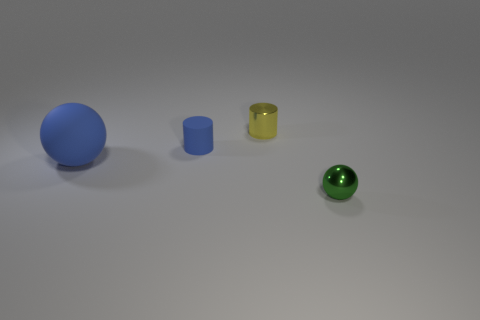Add 3 tiny yellow shiny cylinders. How many objects exist? 7 Subtract all tiny green things. Subtract all big matte balls. How many objects are left? 2 Add 4 blue spheres. How many blue spheres are left? 5 Add 2 tiny rubber cubes. How many tiny rubber cubes exist? 2 Subtract 0 purple cubes. How many objects are left? 4 